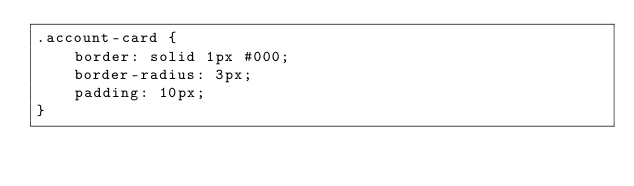Convert code to text. <code><loc_0><loc_0><loc_500><loc_500><_CSS_>.account-card {
    border: solid 1px #000;
    border-radius: 3px;
    padding: 10px;
}</code> 